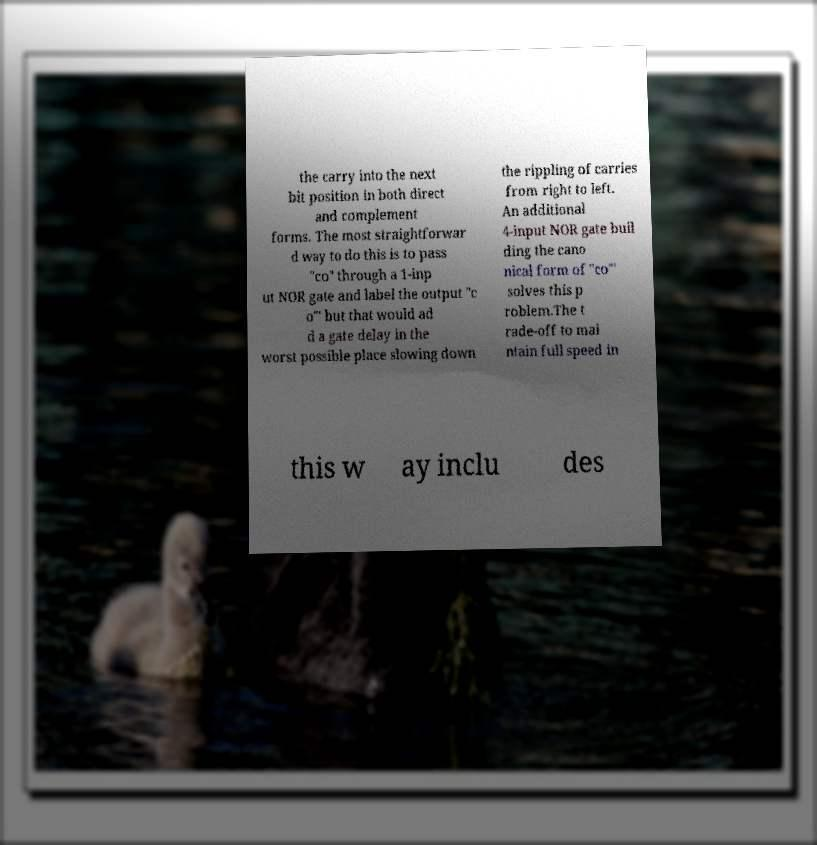What messages or text are displayed in this image? I need them in a readable, typed format. the carry into the next bit position in both direct and complement forms. The most straightforwar d way to do this is to pass "co" through a 1-inp ut NOR gate and label the output "c o"′ but that would ad d a gate delay in the worst possible place slowing down the rippling of carries from right to left. An additional 4-input NOR gate buil ding the cano nical form of "co"′ solves this p roblem.The t rade-off to mai ntain full speed in this w ay inclu des 